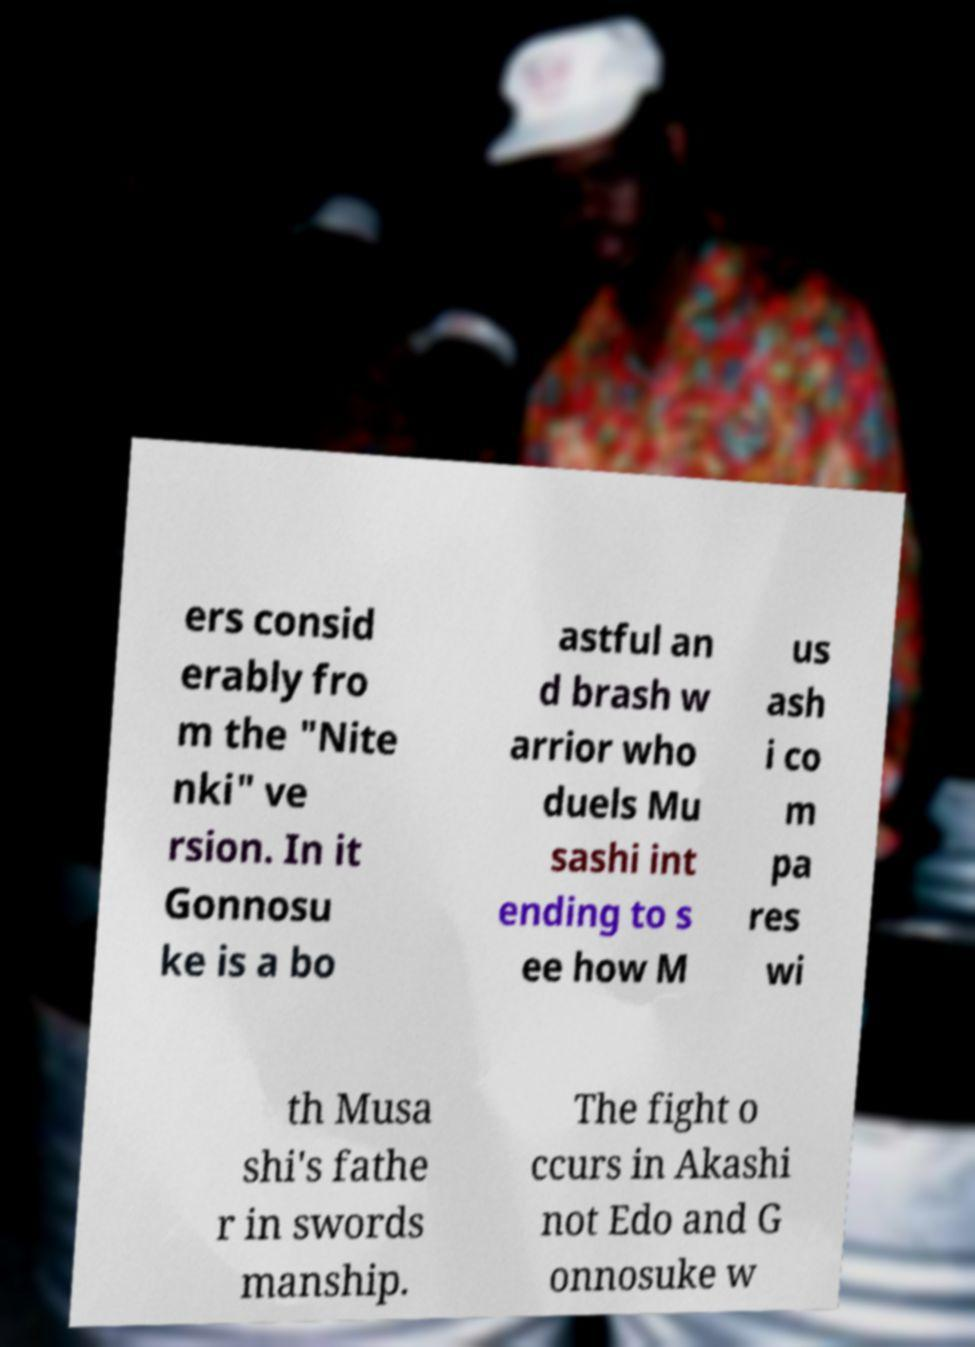Can you read and provide the text displayed in the image?This photo seems to have some interesting text. Can you extract and type it out for me? ers consid erably fro m the "Nite nki" ve rsion. In it Gonnosu ke is a bo astful an d brash w arrior who duels Mu sashi int ending to s ee how M us ash i co m pa res wi th Musa shi's fathe r in swords manship. The fight o ccurs in Akashi not Edo and G onnosuke w 